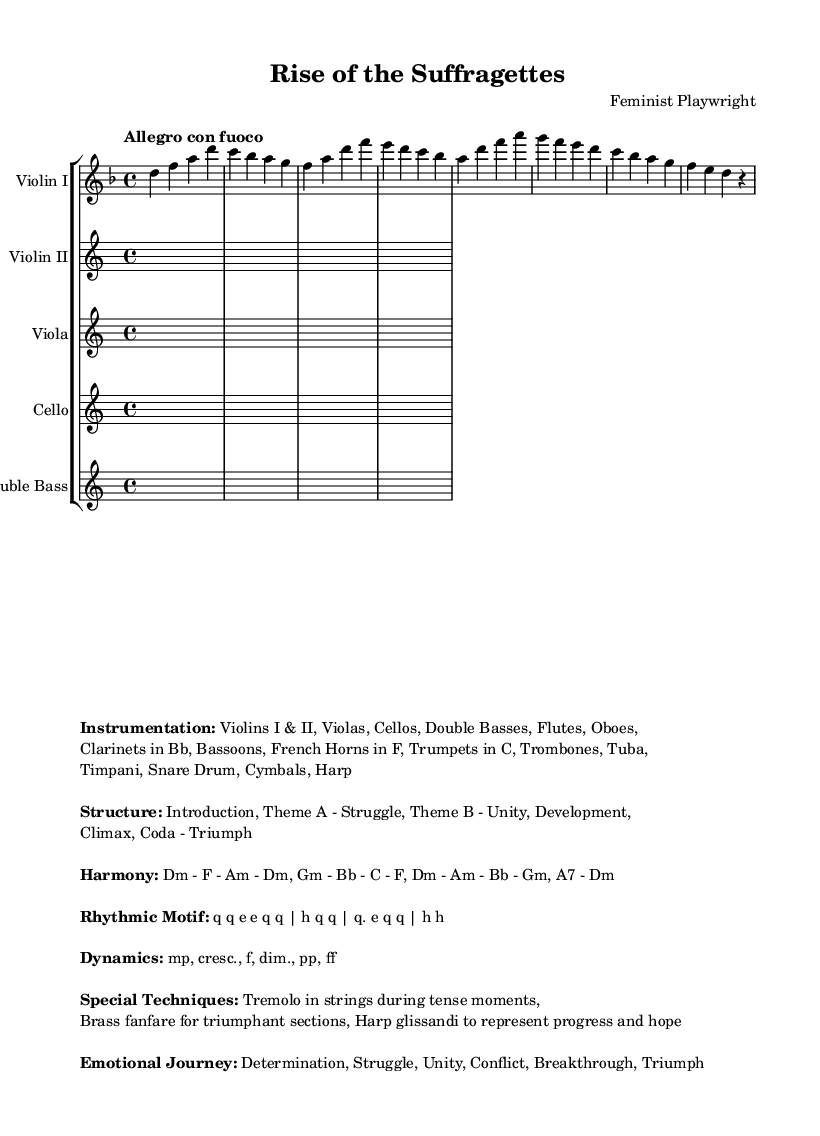What is the key signature of this music? The key signature indicates that there are two flats in the key of D minor. This can be deduced from the global section where the key is declared as D minor.
Answer: D minor What is the time signature of the piece? The time signature is found in the global section of the music, which states 4/4. This means there are four beats in each measure.
Answer: 4/4 What is the tempo marking for this composition? The tempo marking is specified in the global section as "Allegro con fuoco," indicating a fast pace with fire.
Answer: Allegro con fuoco Identify the first theme in the structure. The structure indicates several themes, and the first one mentioned is "Theme A - Struggle." This can be found under the structure section of the markup.
Answer: Theme A - Struggle How many sections are in the overall structure of the piece? The structure layout includes six labeled sections: Introduction, Theme A, Theme B, Development, Climax, and Coda. Counting these provides the total.
Answer: Six Which special technique is used during tense moments? The markup outlines special techniques, indicating that tremolo is used in strings during tense moments. This refers to a rapid repetition of a tone or alternating between two degrees.
Answer: Tremolo What emotional journey does this symphony portray? The emotional journey is described in the markup and includes major sentiments such as Determination, Struggle, Unity, Conflict, Breakthrough, and Triumph, culminating in the triumph of the women's rights movement.
Answer: Determination, Struggle, Unity, Conflict, Breakthrough, Triumph 